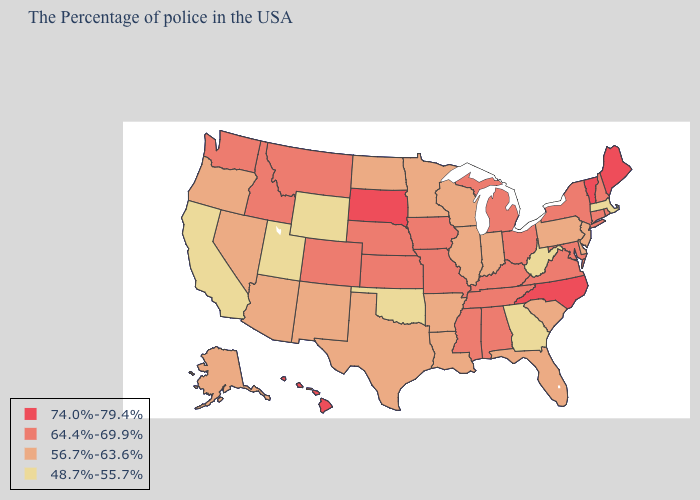Does the first symbol in the legend represent the smallest category?
Quick response, please. No. Name the states that have a value in the range 64.4%-69.9%?
Give a very brief answer. Rhode Island, New Hampshire, Connecticut, New York, Maryland, Virginia, Ohio, Michigan, Kentucky, Alabama, Tennessee, Mississippi, Missouri, Iowa, Kansas, Nebraska, Colorado, Montana, Idaho, Washington. Among the states that border Delaware , which have the lowest value?
Give a very brief answer. New Jersey, Pennsylvania. Name the states that have a value in the range 48.7%-55.7%?
Answer briefly. Massachusetts, West Virginia, Georgia, Oklahoma, Wyoming, Utah, California. What is the lowest value in states that border Minnesota?
Write a very short answer. 56.7%-63.6%. Does Maryland have a higher value than Hawaii?
Short answer required. No. What is the value of Georgia?
Keep it brief. 48.7%-55.7%. Which states have the highest value in the USA?
Give a very brief answer. Maine, Vermont, North Carolina, South Dakota, Hawaii. Does the map have missing data?
Keep it brief. No. Among the states that border New Jersey , does New York have the highest value?
Short answer required. Yes. Does Hawaii have the highest value in the USA?
Short answer required. Yes. What is the value of Kansas?
Write a very short answer. 64.4%-69.9%. What is the value of Delaware?
Write a very short answer. 56.7%-63.6%. What is the highest value in the USA?
Give a very brief answer. 74.0%-79.4%. 